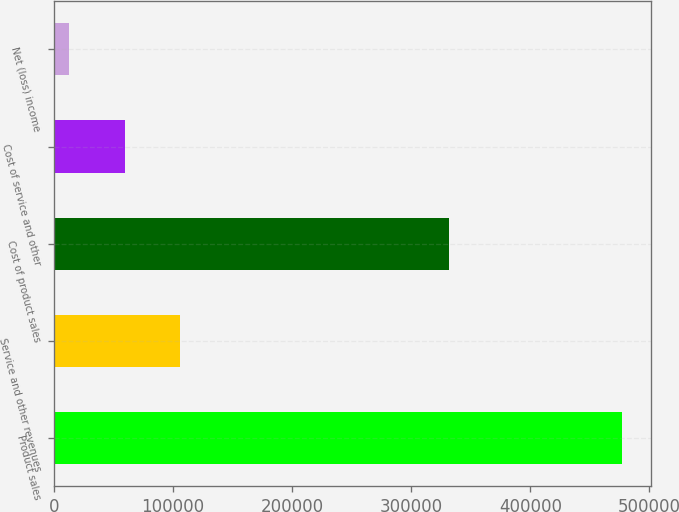Convert chart. <chart><loc_0><loc_0><loc_500><loc_500><bar_chart><fcel>Product sales<fcel>Service and other revenues<fcel>Cost of product sales<fcel>Cost of service and other<fcel>Net (loss) income<nl><fcel>477251<fcel>105901<fcel>331418<fcel>59481.8<fcel>13063<nl></chart> 